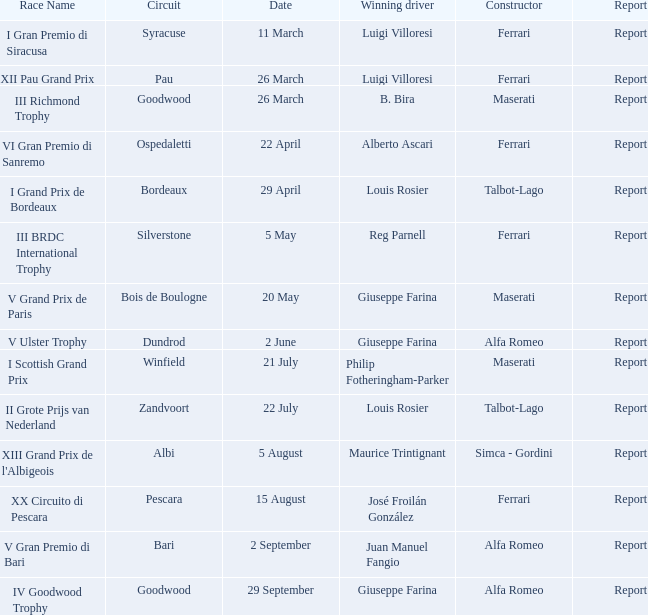Identify the document for philip fotheringham-parker Report. 